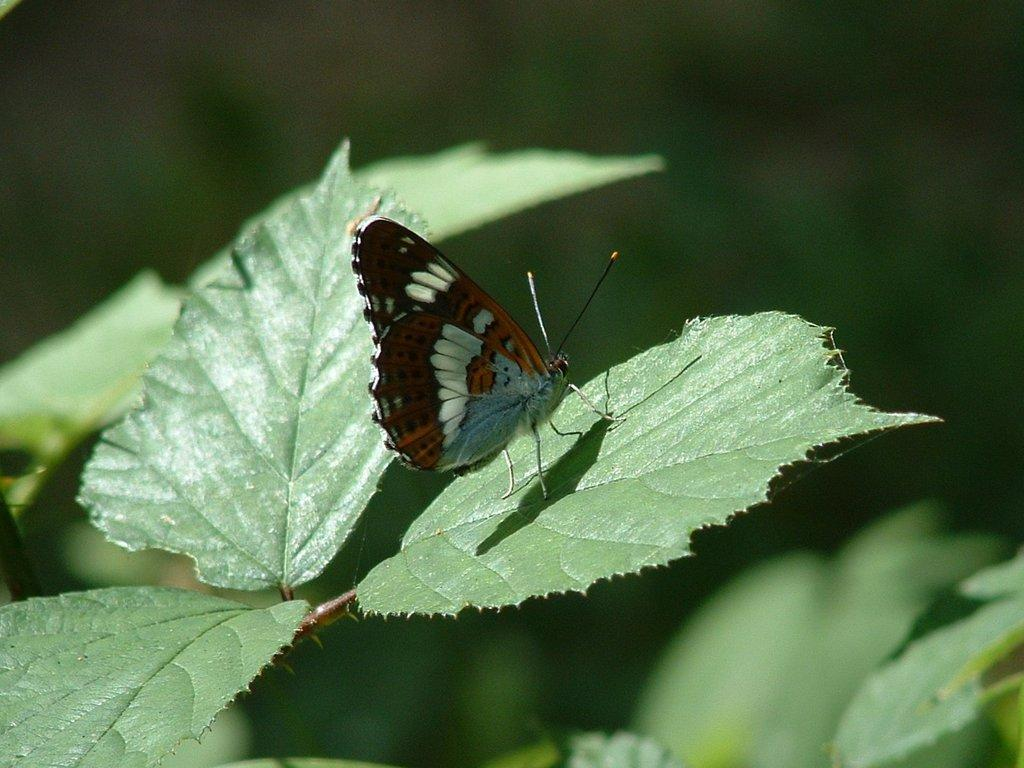What type of living organism can be seen in the image? There is a plant in the image. What other living organism can be seen in the image? There is a butterfly in the image. Can you describe the background of the image? The background of the image is blurred. How many flags are visible in the image? There are no flags present in the image. What type of animal can be seen interacting with the plant in the image? There is no animal present in the image; only the plant and the butterfly are visible. 